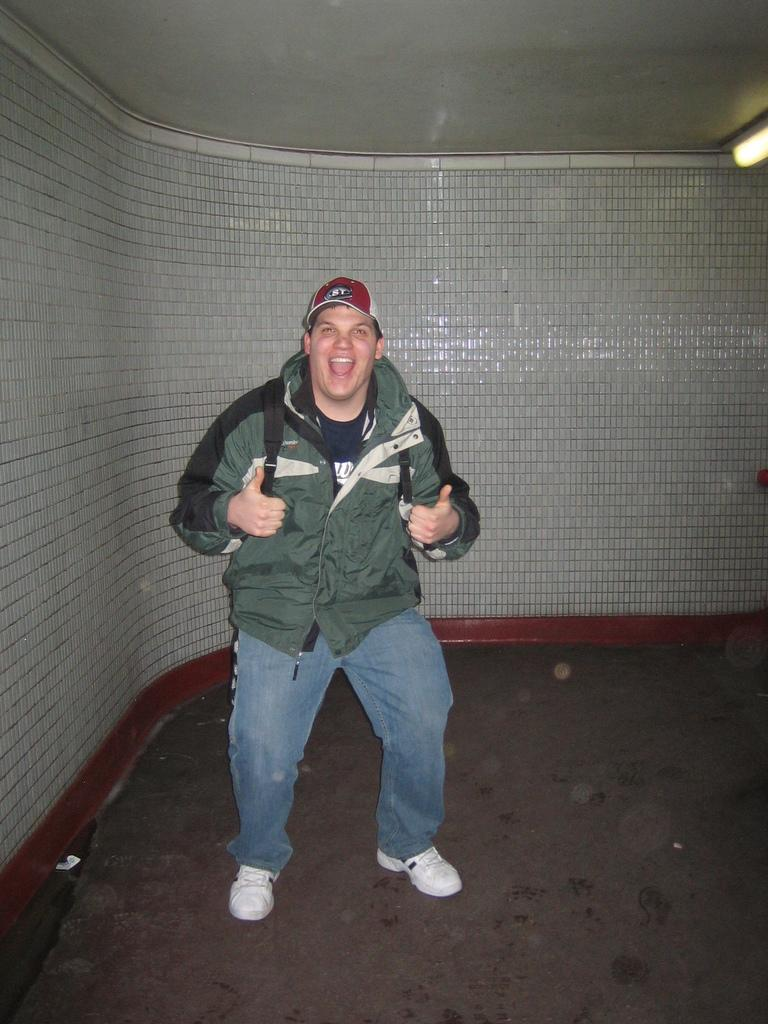What is the main subject of the image? There is a person standing in the image. Can you describe the person's clothing? The person is wearing a green and black color jacket and jeans. What accessory is the person wearing in the image? The person is wearing a bag. What can be seen in the background of the image? There is a white and maroon color wall in the background of the image. What type of toothpaste is the person using in the image? There is no toothpaste present in the image; it features a person standing with specific clothing and a bag. What badge does the person have on their jacket in the image? There is no badge visible on the person's jacket in the image. 